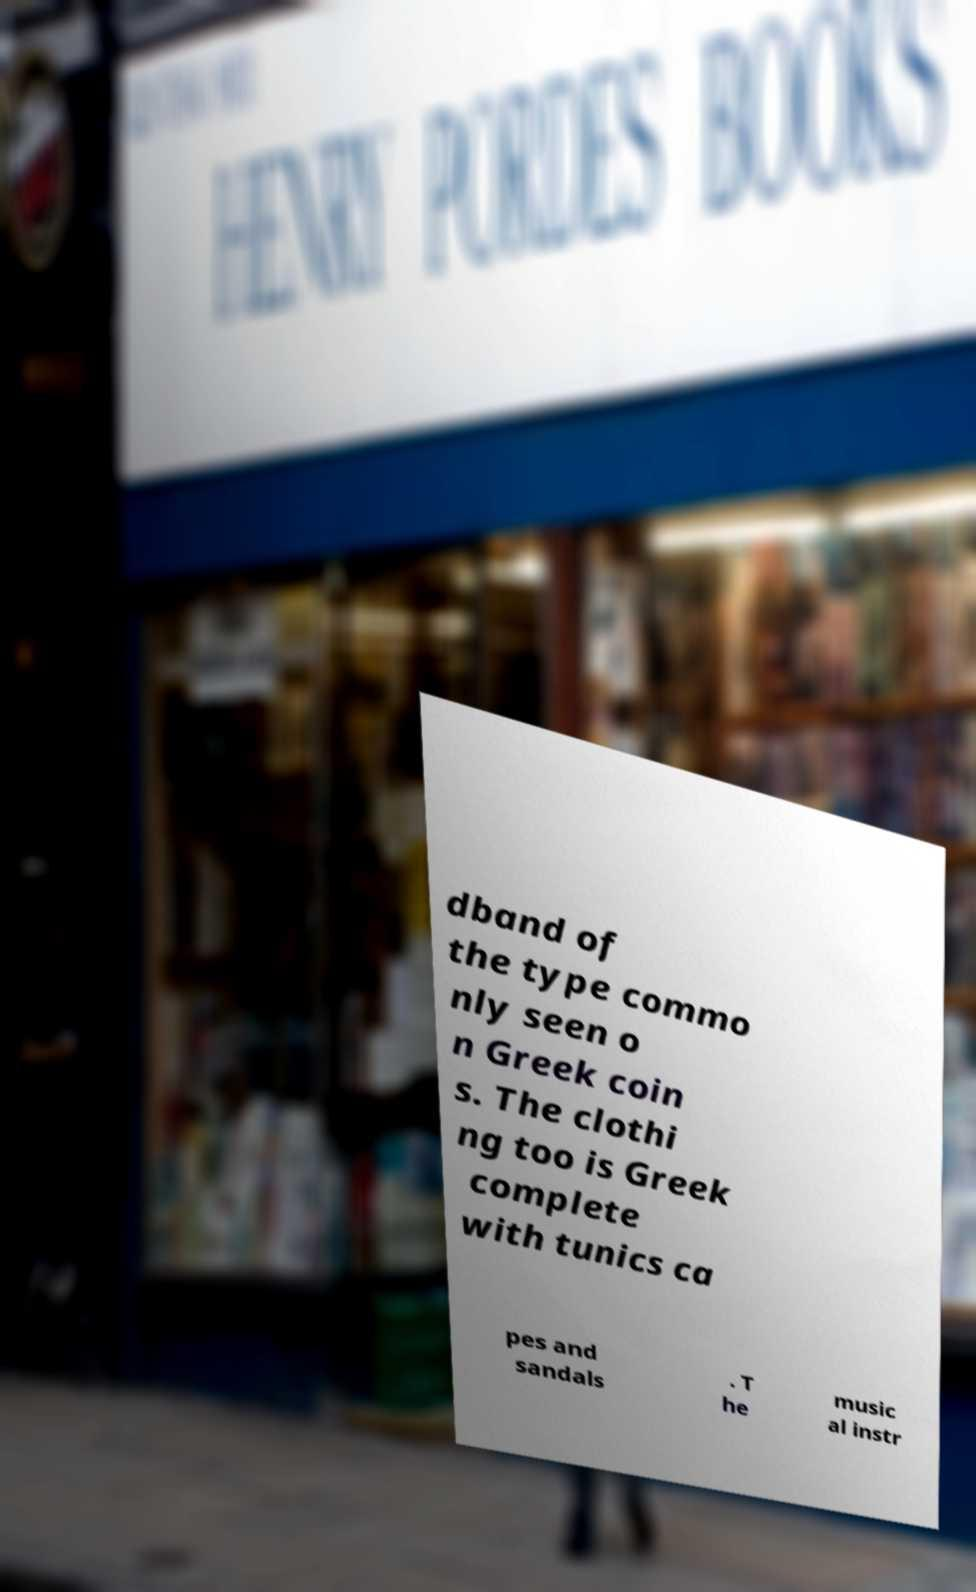Could you assist in decoding the text presented in this image and type it out clearly? dband of the type commo nly seen o n Greek coin s. The clothi ng too is Greek complete with tunics ca pes and sandals . T he music al instr 